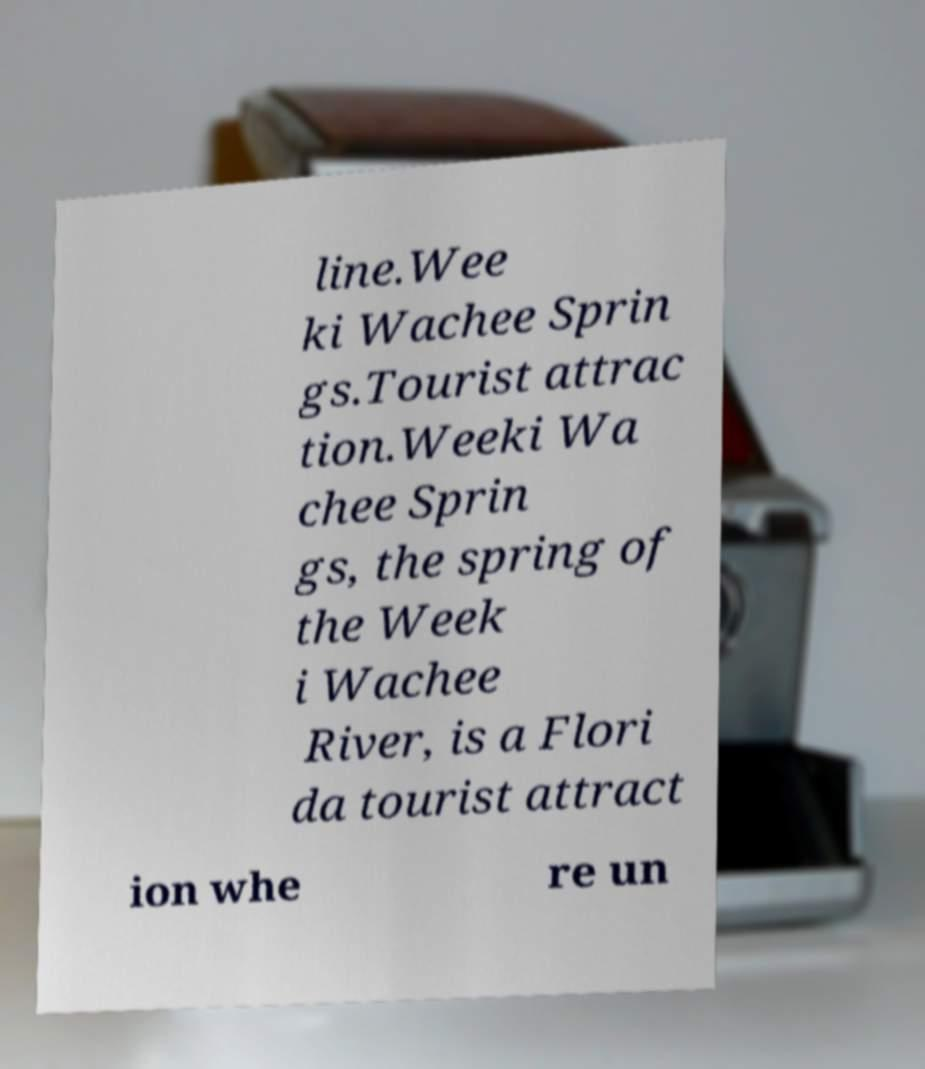Could you assist in decoding the text presented in this image and type it out clearly? line.Wee ki Wachee Sprin gs.Tourist attrac tion.Weeki Wa chee Sprin gs, the spring of the Week i Wachee River, is a Flori da tourist attract ion whe re un 